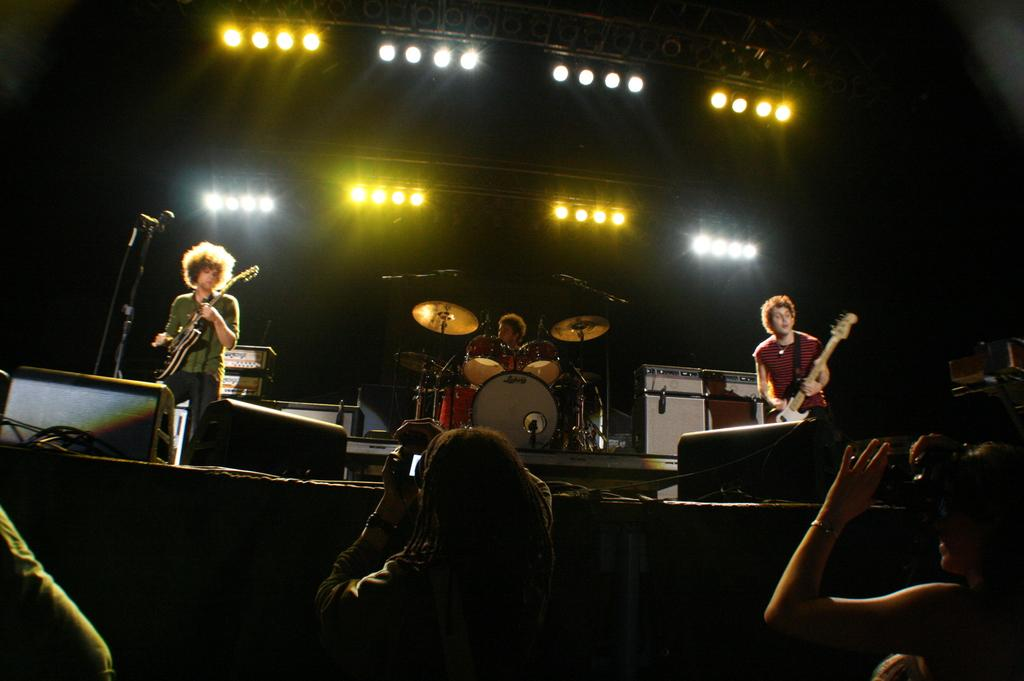How many persons are playing musical instruments in the image? There are three persons playing musical instruments in the image. What is the object in the image that resembles a mile? There is a mile in the image, which is typically used for amplifying sound. What can be seen in the image that might be used for illumination? There are lights visible in the image. What type of equipment is present in the image for producing sound? There are speakers in the image. How many people are visible in the image? There are few persons in the image. What is the color of the background in the image? The background of the image is dark. What type of seed is being planted in the image? There is no seed or planting activity present in the image. How does the image depict a state of peace? The image does not depict a state of peace; it features three persons playing musical instruments and related equipment. 